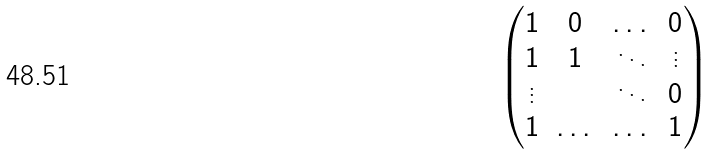<formula> <loc_0><loc_0><loc_500><loc_500>\begin{pmatrix} 1 & 0 & \dots & 0 \\ 1 & 1 & \ddots & \vdots \\ \vdots & & \ddots & 0 \\ 1 & \dots & \dots & 1 \\ \end{pmatrix}</formula> 